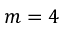Convert formula to latex. <formula><loc_0><loc_0><loc_500><loc_500>m = 4</formula> 